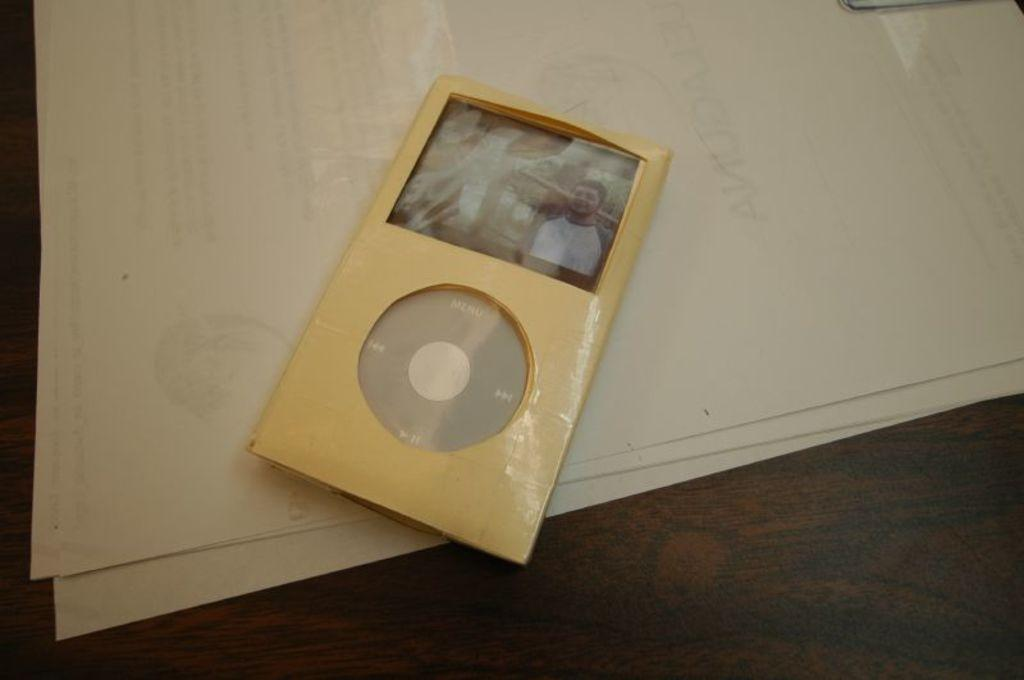What electronic device is visible in the image? There is an iPod in the image. What else can be seen on the table in the image? There are papers on the table in the image. Where is the drawer located in the image? There is no drawer present in the image. What type of tank is visible in the image? There is no tank present in the image. 